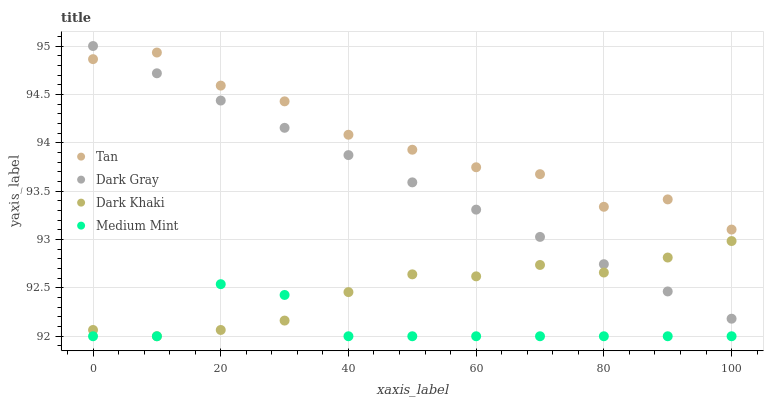Does Medium Mint have the minimum area under the curve?
Answer yes or no. Yes. Does Tan have the maximum area under the curve?
Answer yes or no. Yes. Does Dark Khaki have the minimum area under the curve?
Answer yes or no. No. Does Dark Khaki have the maximum area under the curve?
Answer yes or no. No. Is Dark Gray the smoothest?
Answer yes or no. Yes. Is Tan the roughest?
Answer yes or no. Yes. Is Dark Khaki the smoothest?
Answer yes or no. No. Is Dark Khaki the roughest?
Answer yes or no. No. Does Dark Khaki have the lowest value?
Answer yes or no. Yes. Does Tan have the lowest value?
Answer yes or no. No. Does Dark Gray have the highest value?
Answer yes or no. Yes. Does Dark Khaki have the highest value?
Answer yes or no. No. Is Medium Mint less than Tan?
Answer yes or no. Yes. Is Tan greater than Medium Mint?
Answer yes or no. Yes. Does Dark Gray intersect Tan?
Answer yes or no. Yes. Is Dark Gray less than Tan?
Answer yes or no. No. Is Dark Gray greater than Tan?
Answer yes or no. No. Does Medium Mint intersect Tan?
Answer yes or no. No. 